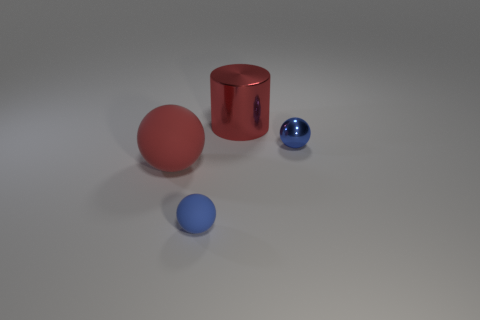Add 3 tiny blue spheres. How many objects exist? 7 Subtract all cylinders. How many objects are left? 3 Subtract 0 brown cylinders. How many objects are left? 4 Subtract all rubber things. Subtract all blue objects. How many objects are left? 0 Add 1 small metallic objects. How many small metallic objects are left? 2 Add 3 red cylinders. How many red cylinders exist? 4 